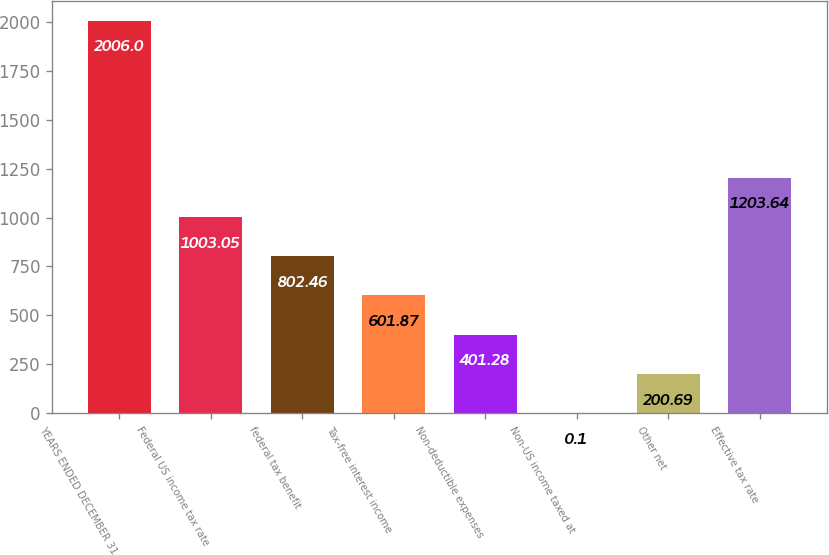Convert chart. <chart><loc_0><loc_0><loc_500><loc_500><bar_chart><fcel>YEARS ENDED DECEMBER 31<fcel>Federal US income tax rate<fcel>federal tax benefit<fcel>Tax-free interest income<fcel>Non-deductible expenses<fcel>Non-US income taxed at<fcel>Other net<fcel>Effective tax rate<nl><fcel>2006<fcel>1003.05<fcel>802.46<fcel>601.87<fcel>401.28<fcel>0.1<fcel>200.69<fcel>1203.64<nl></chart> 